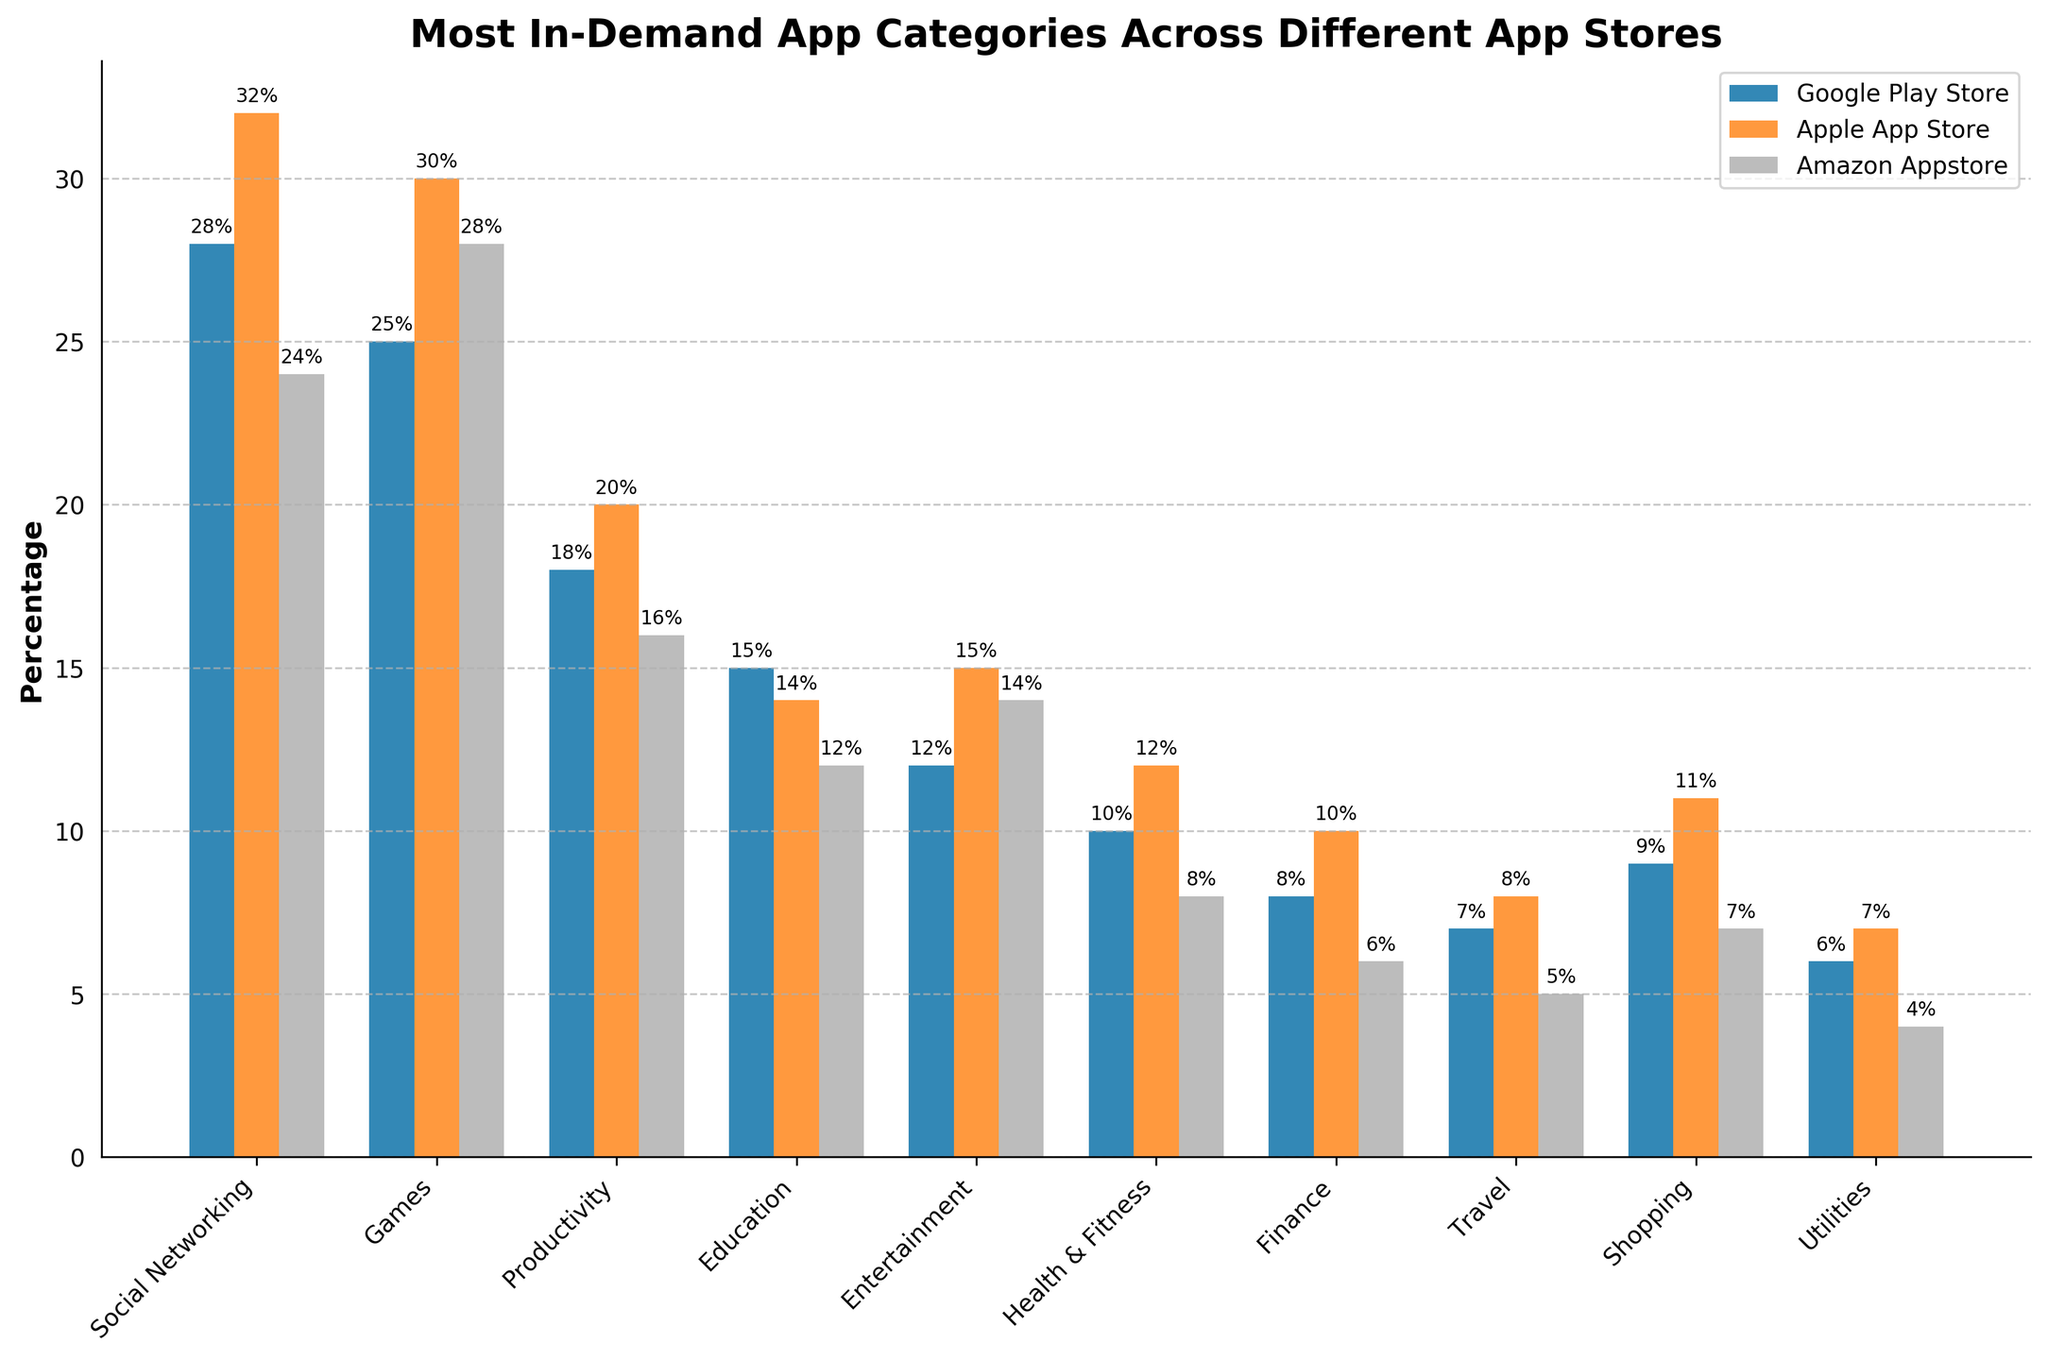Which app category is the most in-demand on the Google Play Store? The bar corresponding to "Social Networking" is the tallest among the categories for the Google Play Store. This indicates that Social Networking has the highest percentage demand.
Answer: Social Networking Between the Games category on the Apple App Store and the Google Play Store, which has a higher demand? The bar representing Games on the Apple App Store is taller than the bar for the same category on the Google Play Store.
Answer: Apple App Store What is the combined percentage demand for the Education category across all three app stores? Adding the percentages for Education (Google Play Store: 15, Apple App Store: 14, Amazon Appstore: 12) gives 15 + 14 + 12 = 41%.
Answer: 41% Which app store has the least demand for Health & Fitness apps? The bar for Health & Fitness in the Amazon Appstore is the shortest compared to the other two app stores.
Answer: Amazon Appstore How does the demand for Shopping apps on the Apple App Store compare to the Amazon Appstore? The bar for Shopping apps on the Apple App Store is taller than that on the Amazon Appstore.
Answer: Higher In which app category is the smallest difference in demand between the Google Play Store and the Apple App Store? By visually comparing the bars closely, the Education category has the smallest difference in height between the Google Play Store (15%) and the Apple App Store (14%), making a difference of 1%.
Answer: Education What is the percentage difference for the Productivity category between the Google Play Store and the Amazon Appstore? Subtract the percentage of Productivity on Amazon Appstore from that on the Google Play Store: (18 - 16 = 2).
Answer: 2% Which category has the most significant variation in demand across the three app stores? By comparing the height differences, Social Networking has the largest variation in demand with the values being 28% (Google Play Store), 32% (Apple App Store), and 24% (Amazon Appstore).
Answer: Social Networking For the Entertainment category, what is the average demand across all three app stores? Add the percentages for Entertainment (Google Play Store: 12, Apple App Store: 15, Amazon Appstore: 14) and divide by 3: (12 + 15 + 14) / 3 = 41 / 3 ≈ 13.67%.
Answer: 13.67% 